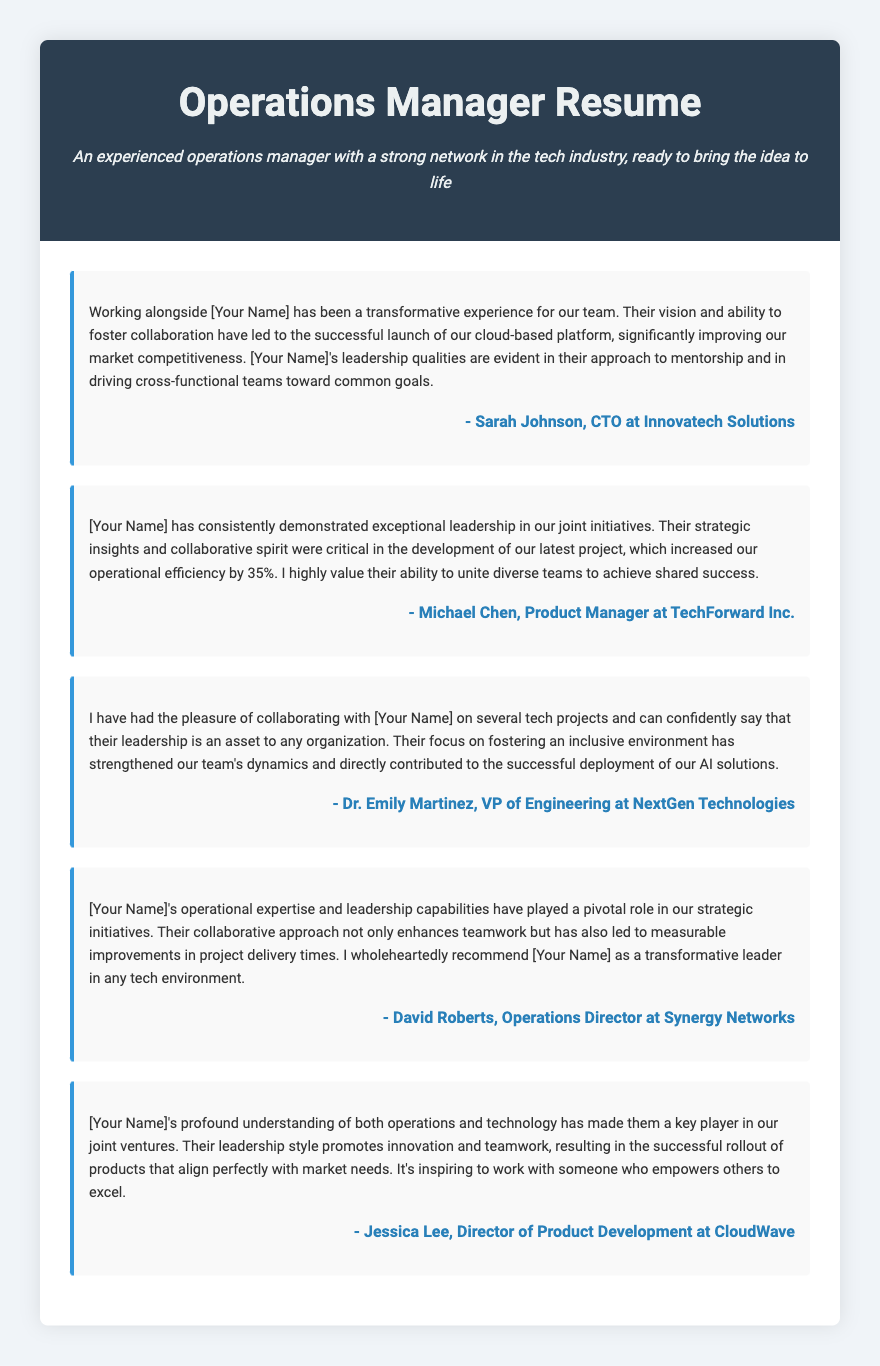What is the name of the CTO who provided a testimonial? The CTO who provided a testimonial is Sarah Johnson.
Answer: Sarah Johnson What percentage did operational efficiency increase in the latest project? The operational efficiency increased by 35%.
Answer: 35% Which organization is Dr. Emily Martinez affiliated with? Dr. Emily Martinez is affiliated with NextGen Technologies.
Answer: NextGen Technologies What role does David Roberts hold? David Roberts holds the position of Operations Director.
Answer: Operations Director How many testimonials are included in the document? There are five testimonials in total.
Answer: Five What is emphasized in Jessica Lee's testimonial about the leadership style? Jessica Lee emphasizes that the leadership style promotes innovation and teamwork.
Answer: Innovation and teamwork Which skill is highlighted as an asset by Dr. Emily Martinez? Dr. Emily Martinez highlights leadership as an asset.
Answer: Leadership What was the key focus of the collaboration mentioned in Michael Chen’s testimonial? The key focus of the collaboration was strategic insights and a collaborative spirit.
Answer: Strategic insights and collaborative spirit What type of projects did the testimonials primarily pertain to? The testimonials primarily pertain to tech projects.
Answer: Tech projects 